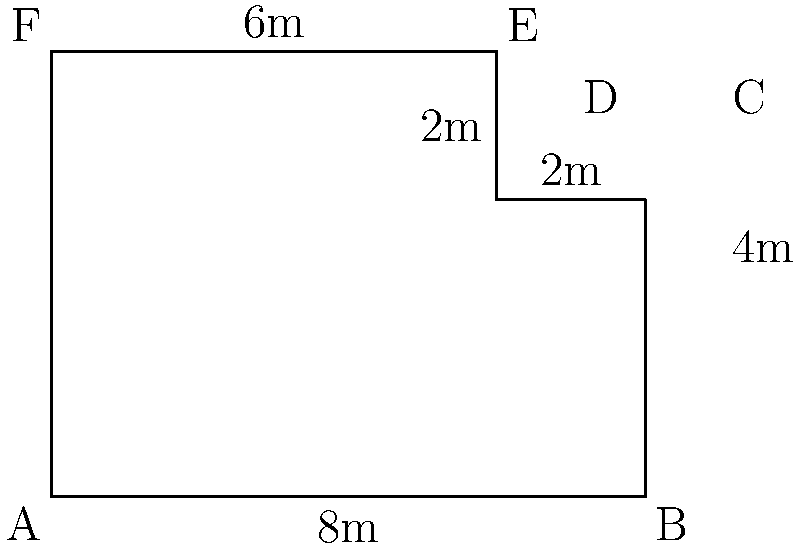Hey, wise guy! Your liquor store's got a weird shape, and the city's breathin' down your neck about square footage. Calculate the total floor area of this irregularly shaped store. All measurements are in meters, and don't forget – every inch counts when you're dealin' with the suits! Alright, let's break this down like we're splittin' a bottle of cheap whiskey:

1) First, we'll divide this oddball shape into two rectangles. Why make life harder, right?

2) The big rectangle (let's call it Rectangle 1):
   Length = 8m, Width = 6m
   Area of Rectangle 1 = $8 \times 6 = 48$ sq meters

3) The small rectangle sticking out (Rectangle 2):
   Length = 2m, Width = 4m
   Area of Rectangle 2 = $2 \times 4 = 8$ sq meters

4) Total area is just these two added together:
   Total Area = Area of Rectangle 1 + Area of Rectangle 2
               = $48 + 8 = 56$ sq meters

There ya have it. 56 square meters of prime booze-sellin' real estate. Now go stick it to the city planners!
Answer: 56 sq meters 